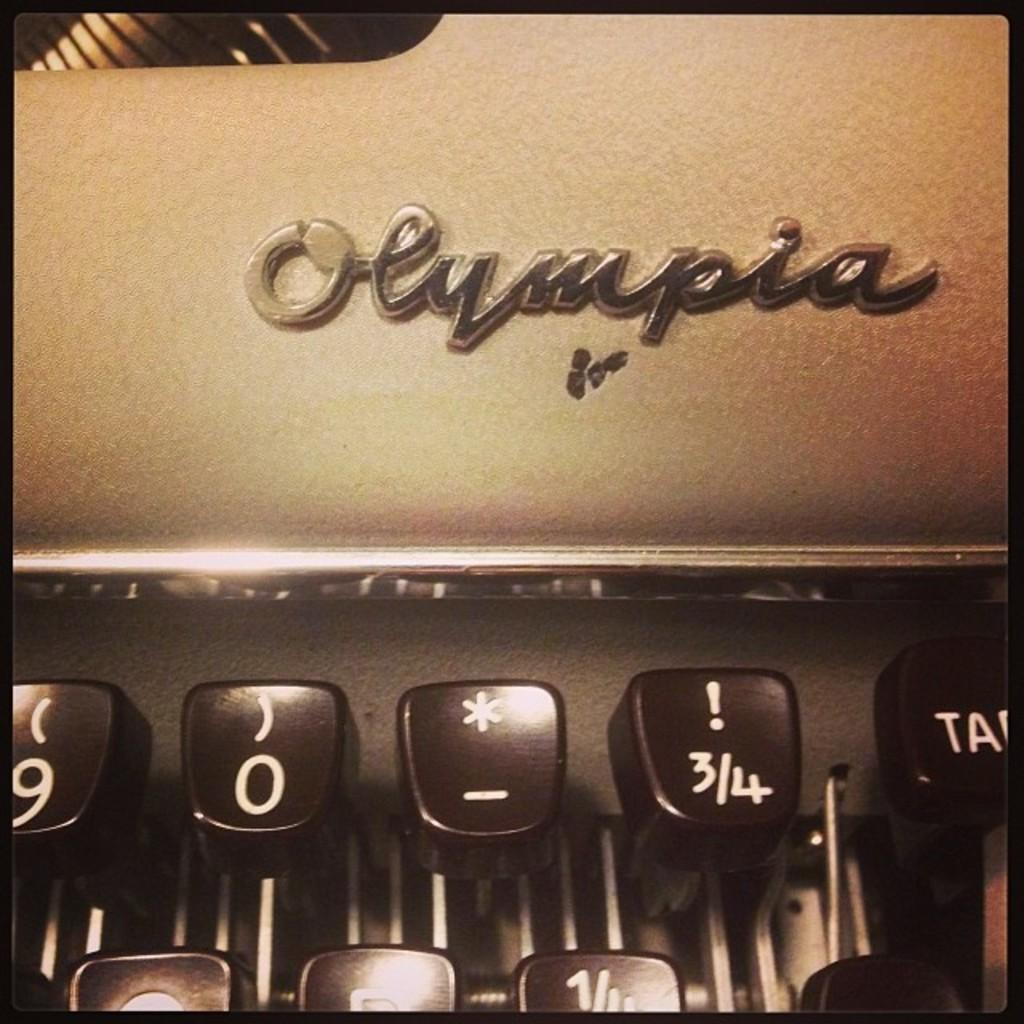What is the main object in the image? There is a typewriter in the image. What degree does the person using the typewriter have in the image? There is no person using the typewriter or any indication of a degree in the image. What type of toothbrush is visible in the image? There is no toothbrush present in the image. How many horses are visible in the image? There are no horses present in the image. 